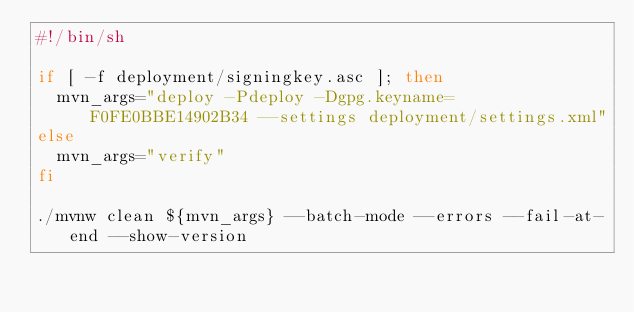<code> <loc_0><loc_0><loc_500><loc_500><_Bash_>#!/bin/sh

if [ -f deployment/signingkey.asc ]; then
  mvn_args="deploy -Pdeploy -Dgpg.keyname=F0FE0BBE14902B34 --settings deployment/settings.xml"
else
  mvn_args="verify"
fi

./mvnw clean ${mvn_args} --batch-mode --errors --fail-at-end --show-version</code> 